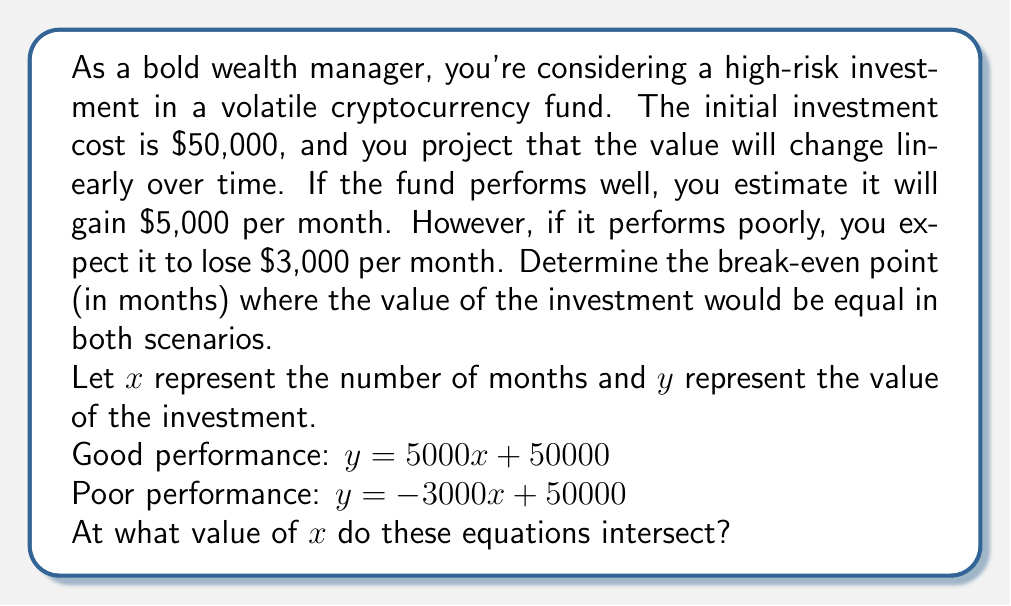Can you answer this question? To find the break-even point, we need to solve the system of linear equations:

$$\begin{align}
y &= 5000x + 50000 \\
y &= -3000x + 50000
\end{align}$$

At the break-even point, these equations are equal. So we can set them equal to each other:

$$5000x + 50000 = -3000x + 50000$$

Now, let's solve for $x$:

1) First, subtract 50000 from both sides:
   $$5000x = -3000x$$

2) Add 3000x to both sides:
   $$8000x = 0$$

3) Divide both sides by 8000:
   $$x = 0$$

The break-even point occurs at $x = 0$, which means the investment values are equal at the start. This makes sense because both equations have the same y-intercept (50000).

To find the investment value at this point, we can substitute $x = 0$ into either equation:

$$y = 5000(0) + 50000 = 50000$$

or

$$y = -3000(0) + 50000 = 50000$$

This confirms that the break-even point occurs at the initial investment value of $50,000.
Answer: The break-even point occurs at 0 months, with an investment value of $50,000. 